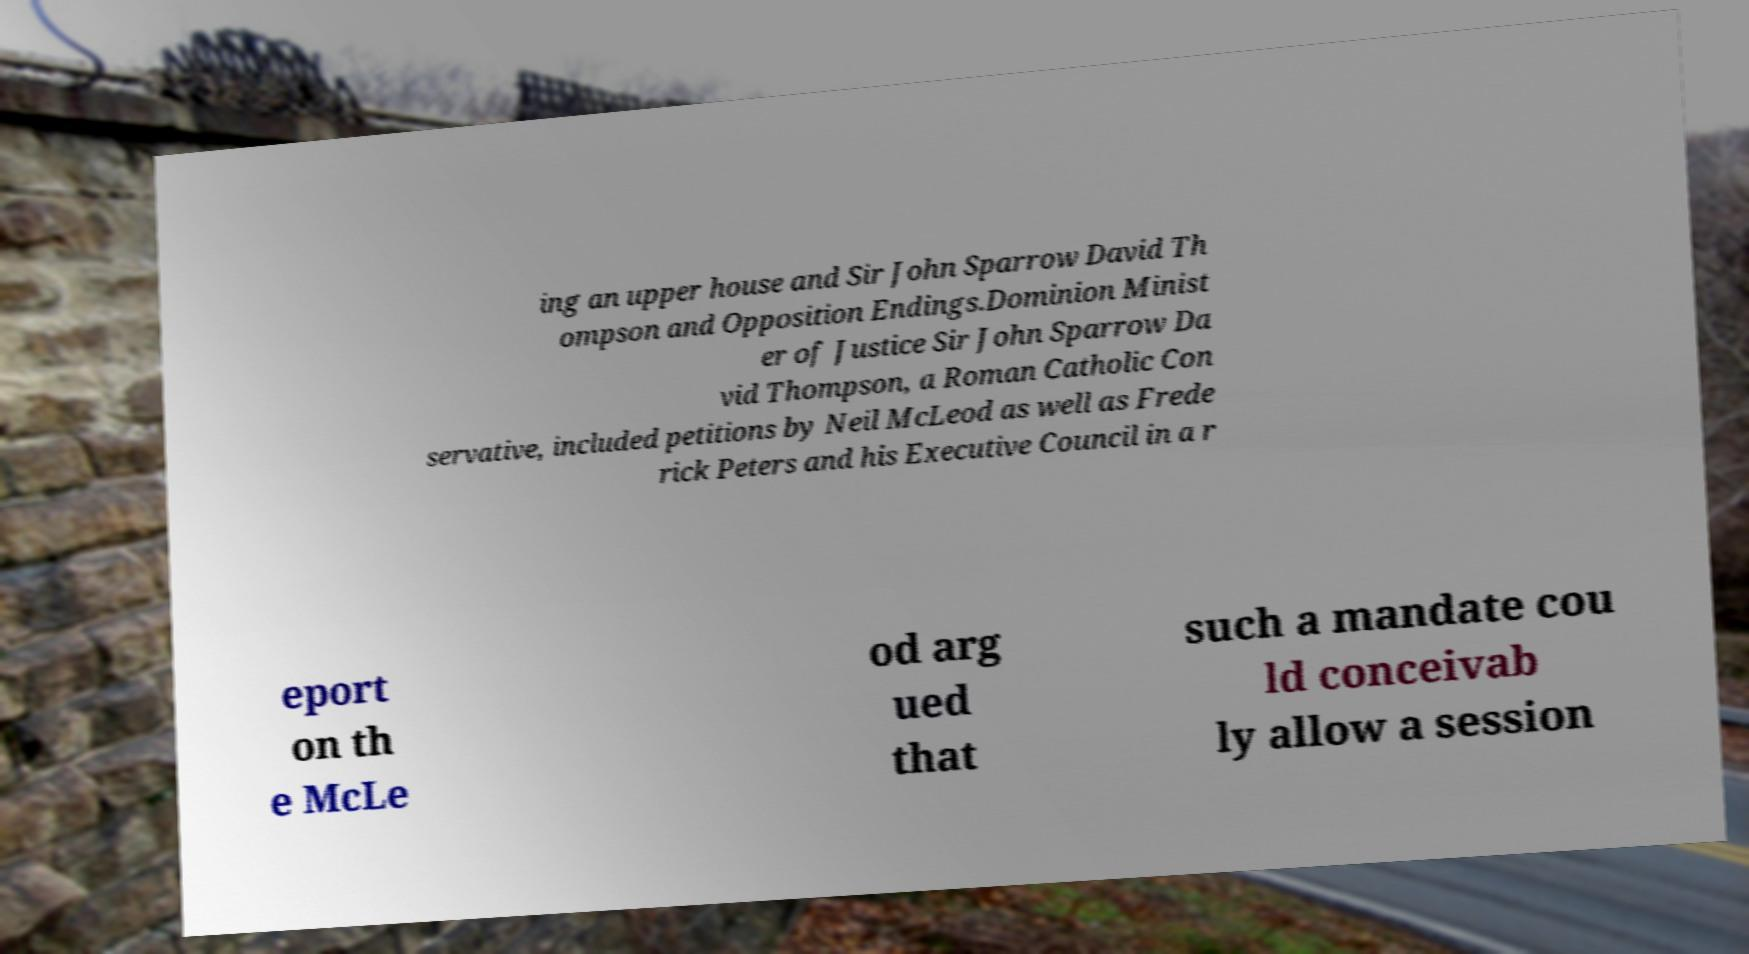Could you extract and type out the text from this image? ing an upper house and Sir John Sparrow David Th ompson and Opposition Endings.Dominion Minist er of Justice Sir John Sparrow Da vid Thompson, a Roman Catholic Con servative, included petitions by Neil McLeod as well as Frede rick Peters and his Executive Council in a r eport on th e McLe od arg ued that such a mandate cou ld conceivab ly allow a session 